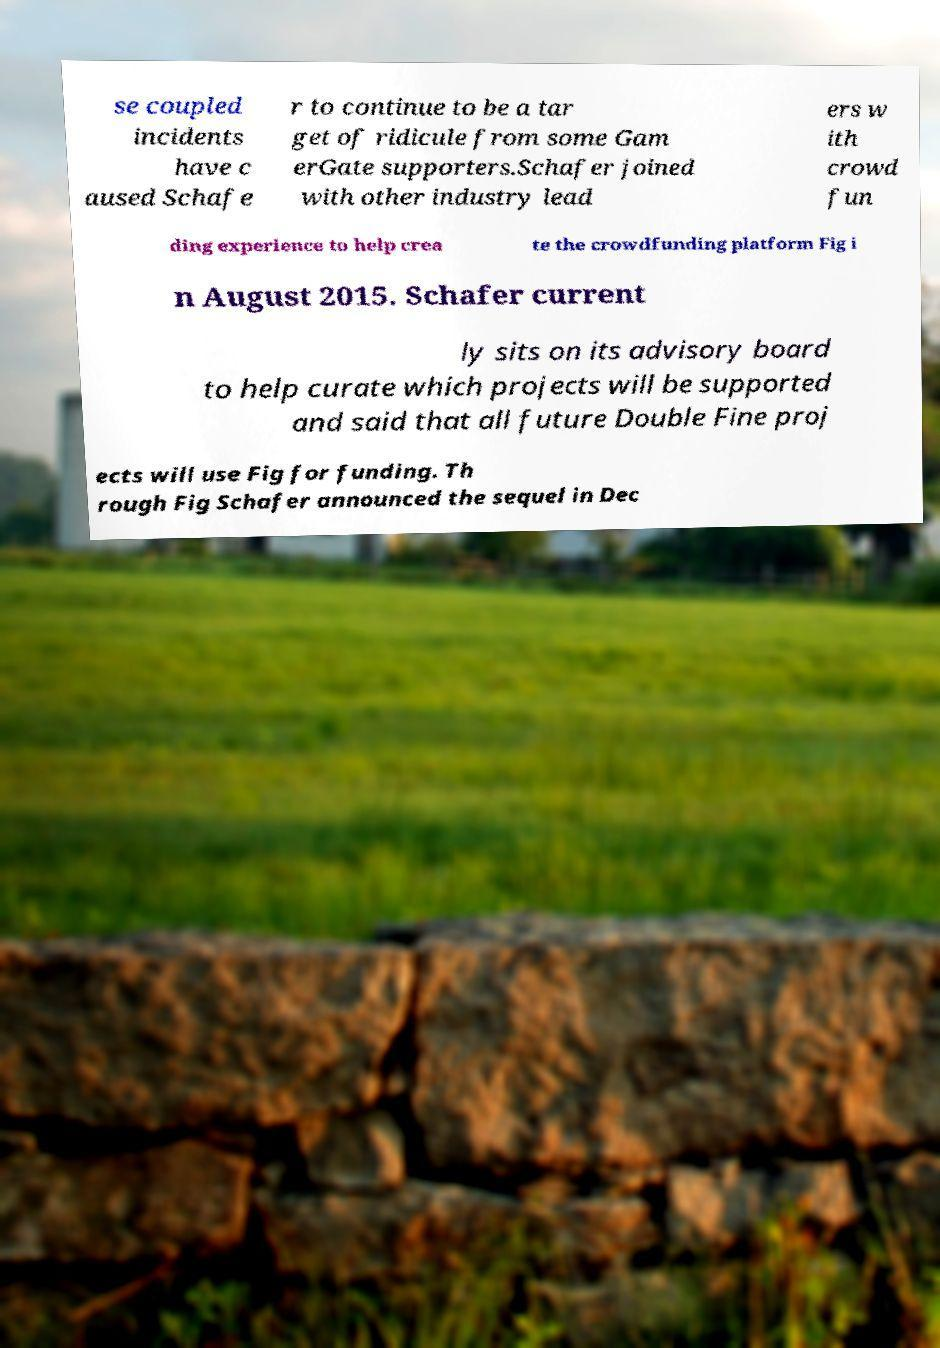Could you extract and type out the text from this image? se coupled incidents have c aused Schafe r to continue to be a tar get of ridicule from some Gam erGate supporters.Schafer joined with other industry lead ers w ith crowd fun ding experience to help crea te the crowdfunding platform Fig i n August 2015. Schafer current ly sits on its advisory board to help curate which projects will be supported and said that all future Double Fine proj ects will use Fig for funding. Th rough Fig Schafer announced the sequel in Dec 